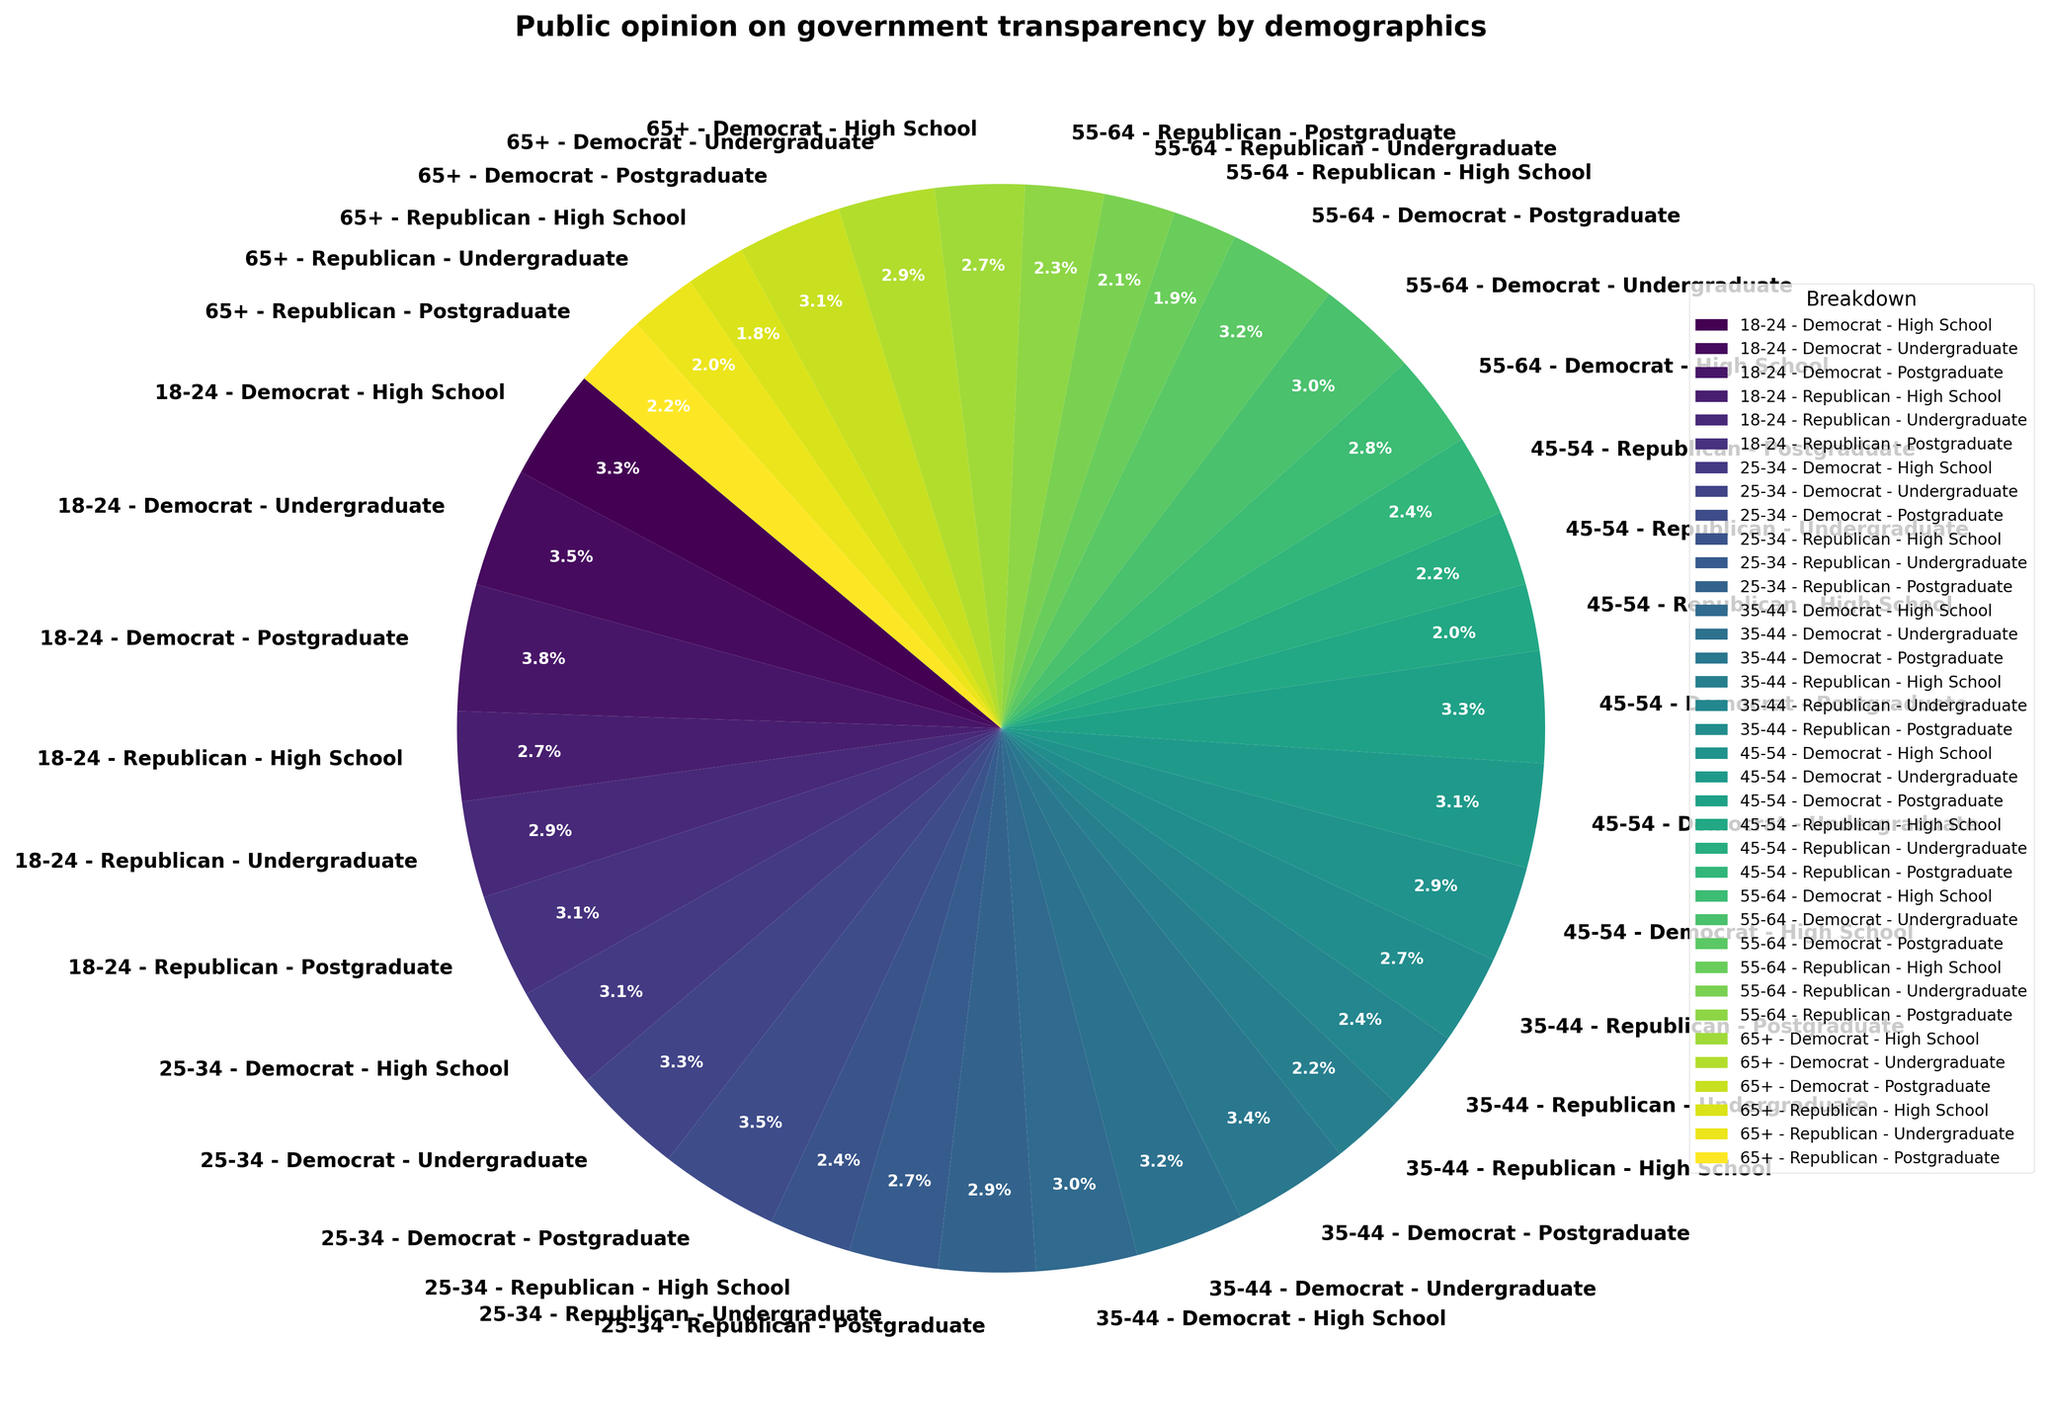What is the overall trend in support for government transparency among Democrats compared to Republicans as age increases? To answer this, look at the outermost layer of the nested pie chart, and observe the overall segments for Democrats versus Republicans across age groups. Democrats generally show higher support for government transparency across all age groups compared to Republicans. As age increases, the difference in support percentages becomes more noticeable because the Democratic segments remain larger or more consistent while Republican segments decrease more significantly.
Answer: Democrats show higher support How does support for government transparency among individuals with a postgraduate education compare between Democrats and Republicans within the 35-44 age group? Find the segments representing individuals aged 35-44 with a postgraduate education for both Democrats and Republicans. Democrats in this age group and education level show a 78% support rate, while Republicans show a 60% support rate.
Answer: Democrats have 78%, Republicans have 60% Which age group with a high school education shows the least support for government transparency, and what is the percentage? Look for the segments representing individuals with a high school education. Compare the transparency support rates across all age groups. The 65+ age group shows the least support with only 40%.
Answer: 65+ with 40% What is the average support percentage for government transparency among Republicans with an undergraduate education across all age groups? To find this, sum the support percentages for Republicans with an undergraduate education in each age group (65, 60, 55, 50, 48, 45) and divide by the number of age groups (6). So, (65+60+55+50+48+45)/6 = 53.83.
Answer: 53.83% Is there a noticeable difference in support for government transparency between individuals aged 25-34 and those aged 55-64, regardless of political affiliation or education level? Observe the segments for the age groups 25-34 and 55-64 across the entire pie chart. Generally, individuals aged 25-34 show slightly higher support than those aged 55-64. This is apparent because the segments for 25-34 seem to be marginally larger or have higher values overall.
Answer: Yes Among Democrats with postgraduates, which age group shows the highest support for government transparency? Focus on the segments representing Democrats with a postgraduate education. Compare the transparency support percentages for different age groups. The 18-24 age group shows the highest support at 85%.
Answer: 18-24 For Republicans aged 45-54, which level of education shows the highest support for government transparency? Find the segments for Republicans aged 45-54 and compare the transparency support rates across different education levels. The postgraduate education level shows the highest support at 55%.
Answer: Postgraduate How does the support for government transparency among individuals aged 18-24 with an undergraduate education compare to those aged 45-54 with the same education level across all political affiliations? Look at the segments for individuals aged 18-24 and 45-54 with an undergraduate education, combining Democrats and Republicans. The 18-24 age group has an average of (80+65)/2 = 72.5%, while the 45-54 group has (70+50)/2 = 60%. Thus, individuals aged 18-24 have higher support.
Answer: 72.5% vs. 60% What can be inferred about the correlation between education level and support for government transparency within the Republican party? Examine the segments within the Republican party across different education levels. Generally, as the education level increases (from high school to postgraduate), the support for government transparency also increases.
Answer: Positive correlation 